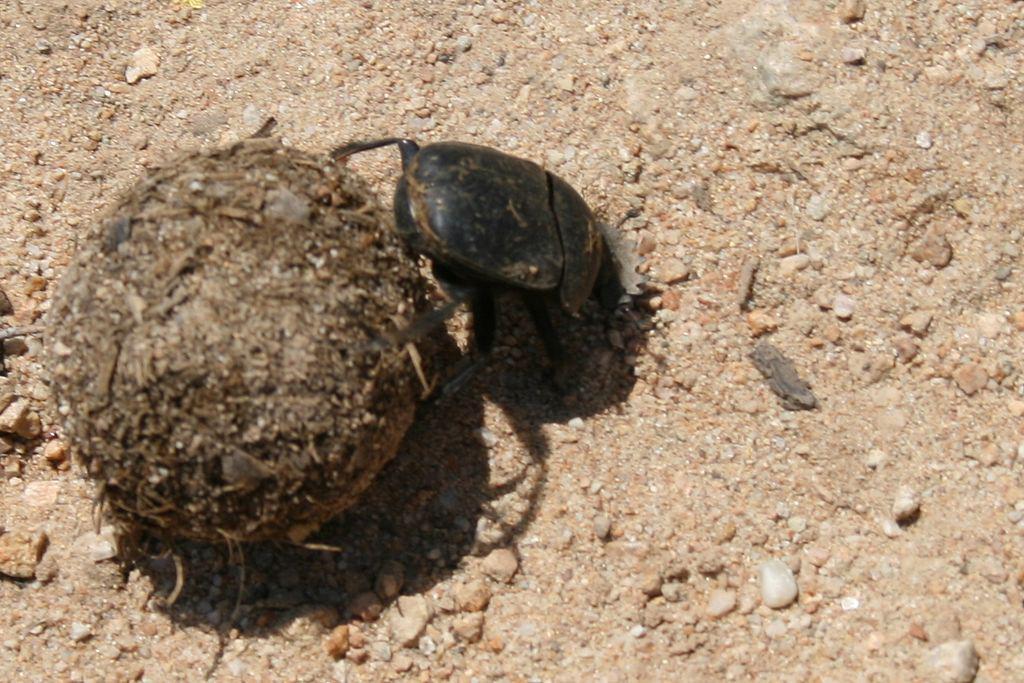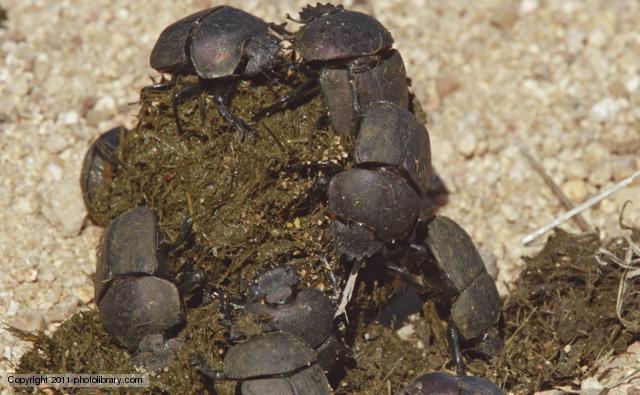The first image is the image on the left, the second image is the image on the right. Analyze the images presented: Is the assertion "An image shows more than one beetle by a shape made of dung." valid? Answer yes or no. Yes. The first image is the image on the left, the second image is the image on the right. Considering the images on both sides, is "There are at least two insects in the image on the right." valid? Answer yes or no. Yes. 